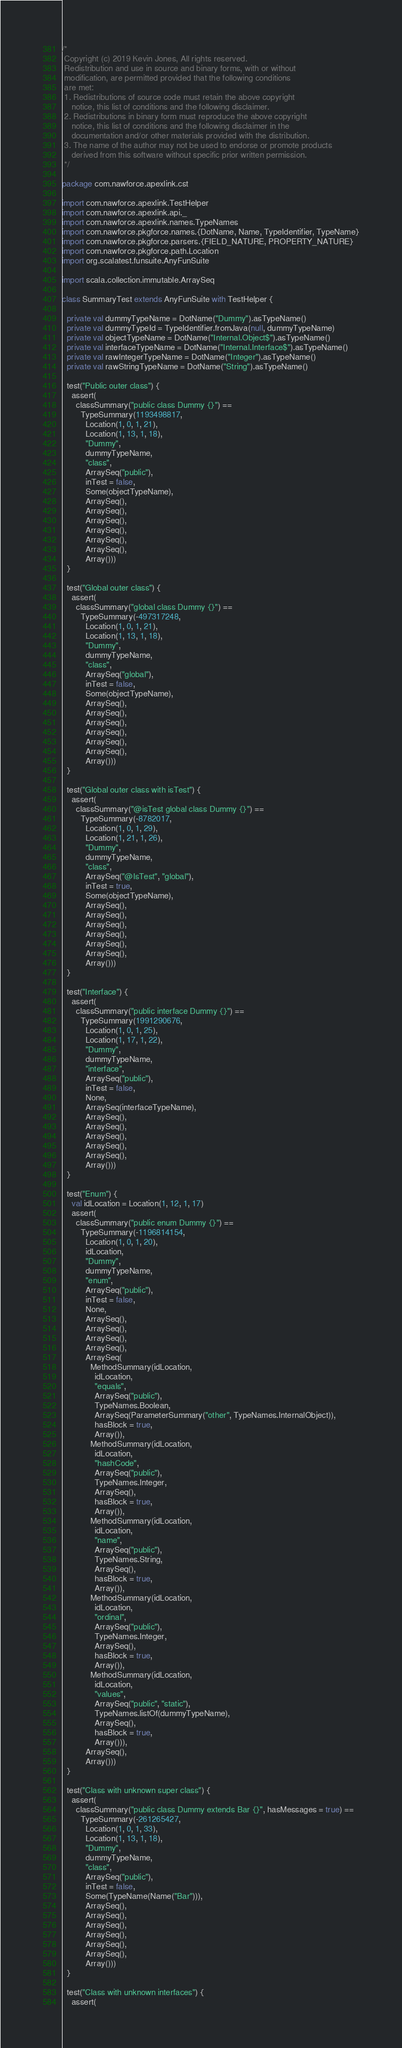Convert code to text. <code><loc_0><loc_0><loc_500><loc_500><_Scala_>/*
 Copyright (c) 2019 Kevin Jones, All rights reserved.
 Redistribution and use in source and binary forms, with or without
 modification, are permitted provided that the following conditions
 are met:
 1. Redistributions of source code must retain the above copyright
    notice, this list of conditions and the following disclaimer.
 2. Redistributions in binary form must reproduce the above copyright
    notice, this list of conditions and the following disclaimer in the
    documentation and/or other materials provided with the distribution.
 3. The name of the author may not be used to endorse or promote products
    derived from this software without specific prior written permission.
 */

package com.nawforce.apexlink.cst

import com.nawforce.apexlink.TestHelper
import com.nawforce.apexlink.api._
import com.nawforce.apexlink.names.TypeNames
import com.nawforce.pkgforce.names.{DotName, Name, TypeIdentifier, TypeName}
import com.nawforce.pkgforce.parsers.{FIELD_NATURE, PROPERTY_NATURE}
import com.nawforce.pkgforce.path.Location
import org.scalatest.funsuite.AnyFunSuite

import scala.collection.immutable.ArraySeq

class SummaryTest extends AnyFunSuite with TestHelper {

  private val dummyTypeName = DotName("Dummy").asTypeName()
  private val dummyTypeId = TypeIdentifier.fromJava(null, dummyTypeName)
  private val objectTypeName = DotName("Internal.Object$").asTypeName()
  private val interfaceTypeName = DotName("Internal.Interface$").asTypeName()
  private val rawIntegerTypeName = DotName("Integer").asTypeName()
  private val rawStringTypeName = DotName("String").asTypeName()

  test("Public outer class") {
    assert(
      classSummary("public class Dummy {}") ==
        TypeSummary(1193498817,
          Location(1, 0, 1, 21),
          Location(1, 13, 1, 18),
          "Dummy",
          dummyTypeName,
          "class",
          ArraySeq("public"),
          inTest = false,
          Some(objectTypeName),
          ArraySeq(),
          ArraySeq(),
          ArraySeq(),
          ArraySeq(),
          ArraySeq(),
          ArraySeq(),
          Array()))
  }

  test("Global outer class") {
    assert(
      classSummary("global class Dummy {}") ==
        TypeSummary(-497317248,
          Location(1, 0, 1, 21),
          Location(1, 13, 1, 18),
          "Dummy",
          dummyTypeName,
          "class",
          ArraySeq("global"),
          inTest = false,
          Some(objectTypeName),
          ArraySeq(),
          ArraySeq(),
          ArraySeq(),
          ArraySeq(),
          ArraySeq(),
          ArraySeq(),
          Array()))
  }

  test("Global outer class with isTest") {
    assert(
      classSummary("@isTest global class Dummy {}") ==
        TypeSummary(-8782017,
          Location(1, 0, 1, 29),
          Location(1, 21, 1, 26),
          "Dummy",
          dummyTypeName,
          "class",
          ArraySeq("@IsTest", "global"),
          inTest = true,
          Some(objectTypeName),
          ArraySeq(),
          ArraySeq(),
          ArraySeq(),
          ArraySeq(),
          ArraySeq(),
          ArraySeq(),
          Array()))
  }

  test("Interface") {
    assert(
      classSummary("public interface Dummy {}") ==
        TypeSummary(1991290676,
          Location(1, 0, 1, 25),
          Location(1, 17, 1, 22),
          "Dummy",
          dummyTypeName,
          "interface",
          ArraySeq("public"),
          inTest = false,
          None,
          ArraySeq(interfaceTypeName),
          ArraySeq(),
          ArraySeq(),
          ArraySeq(),
          ArraySeq(),
          ArraySeq(),
          Array()))
  }

  test("Enum") {
    val idLocation = Location(1, 12, 1, 17)
    assert(
      classSummary("public enum Dummy {}") ==
        TypeSummary(-1196814154,
          Location(1, 0, 1, 20),
          idLocation,
          "Dummy",
          dummyTypeName,
          "enum",
          ArraySeq("public"),
          inTest = false,
          None,
          ArraySeq(),
          ArraySeq(),
          ArraySeq(),
          ArraySeq(),
          ArraySeq(
            MethodSummary(idLocation,
              idLocation,
              "equals",
              ArraySeq("public"),
              TypeNames.Boolean,
              ArraySeq(ParameterSummary("other", TypeNames.InternalObject)),
              hasBlock = true,
              Array()),
            MethodSummary(idLocation,
              idLocation,
              "hashCode",
              ArraySeq("public"),
              TypeNames.Integer,
              ArraySeq(),
              hasBlock = true,
              Array()),
            MethodSummary(idLocation,
              idLocation,
              "name",
              ArraySeq("public"),
              TypeNames.String,
              ArraySeq(),
              hasBlock = true,
              Array()),
            MethodSummary(idLocation,
              idLocation,
              "ordinal",
              ArraySeq("public"),
              TypeNames.Integer,
              ArraySeq(),
              hasBlock = true,
              Array()),
            MethodSummary(idLocation,
              idLocation,
              "values",
              ArraySeq("public", "static"),
              TypeNames.listOf(dummyTypeName),
              ArraySeq(),
              hasBlock = true,
              Array())),
          ArraySeq(),
          Array()))
  }

  test("Class with unknown super class") {
    assert(
      classSummary("public class Dummy extends Bar {}", hasMessages = true) ==
        TypeSummary(-261265427,
          Location(1, 0, 1, 33),
          Location(1, 13, 1, 18),
          "Dummy",
          dummyTypeName,
          "class",
          ArraySeq("public"),
          inTest = false,
          Some(TypeName(Name("Bar"))),
          ArraySeq(),
          ArraySeq(),
          ArraySeq(),
          ArraySeq(),
          ArraySeq(),
          ArraySeq(),
          Array()))
  }

  test("Class with unknown interfaces") {
    assert(</code> 